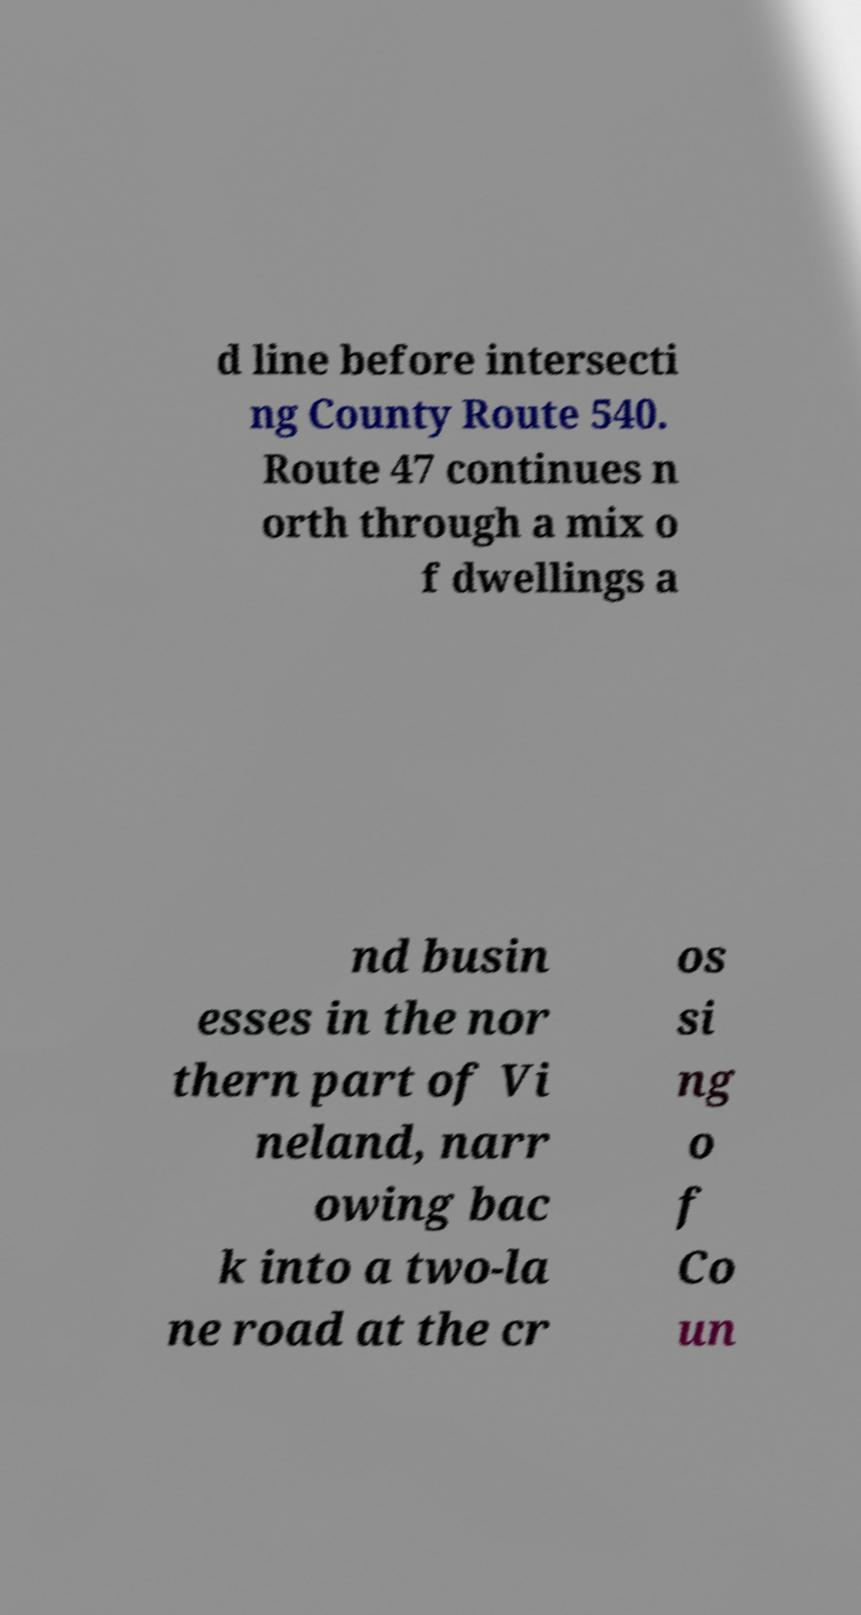What messages or text are displayed in this image? I need them in a readable, typed format. d line before intersecti ng County Route 540. Route 47 continues n orth through a mix o f dwellings a nd busin esses in the nor thern part of Vi neland, narr owing bac k into a two-la ne road at the cr os si ng o f Co un 